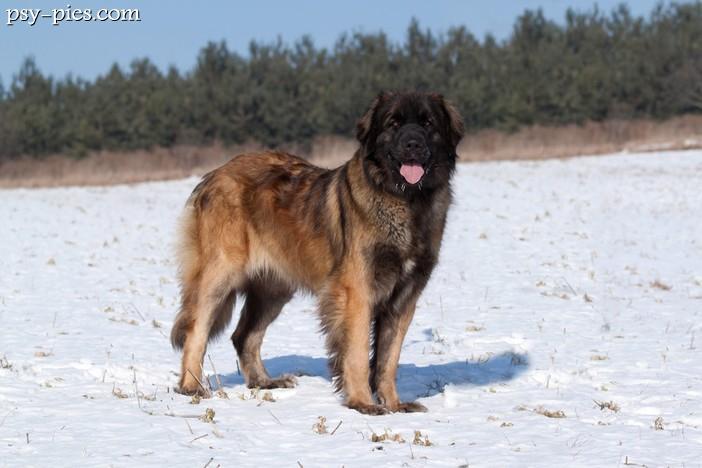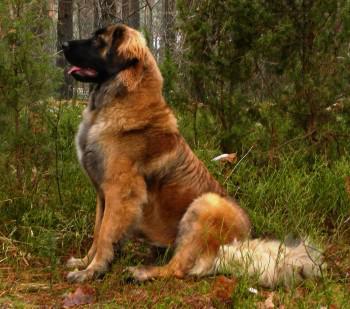The first image is the image on the left, the second image is the image on the right. Considering the images on both sides, is "There are two dogs in one of the images." valid? Answer yes or no. No. 